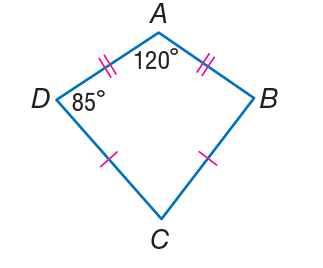Answer the mathemtical geometry problem and directly provide the correct option letter.
Question: If A B C D is a kite. Find m \angle C.
Choices: A: 60 B: 70 C: 85 D: 120 B 